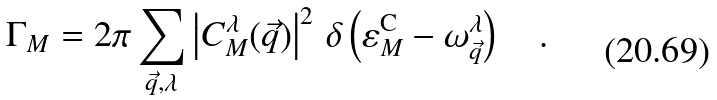Convert formula to latex. <formula><loc_0><loc_0><loc_500><loc_500>\Gamma _ { M } = 2 \pi \sum _ { \vec { q } , \lambda } \left | C ^ { \lambda } _ { M } ( \vec { q } ) \right | ^ { 2 } \, \delta \left ( \varepsilon _ { M } ^ { \text {C} } - \omega _ { \vec { q } } ^ { \lambda } \right ) \quad .</formula> 